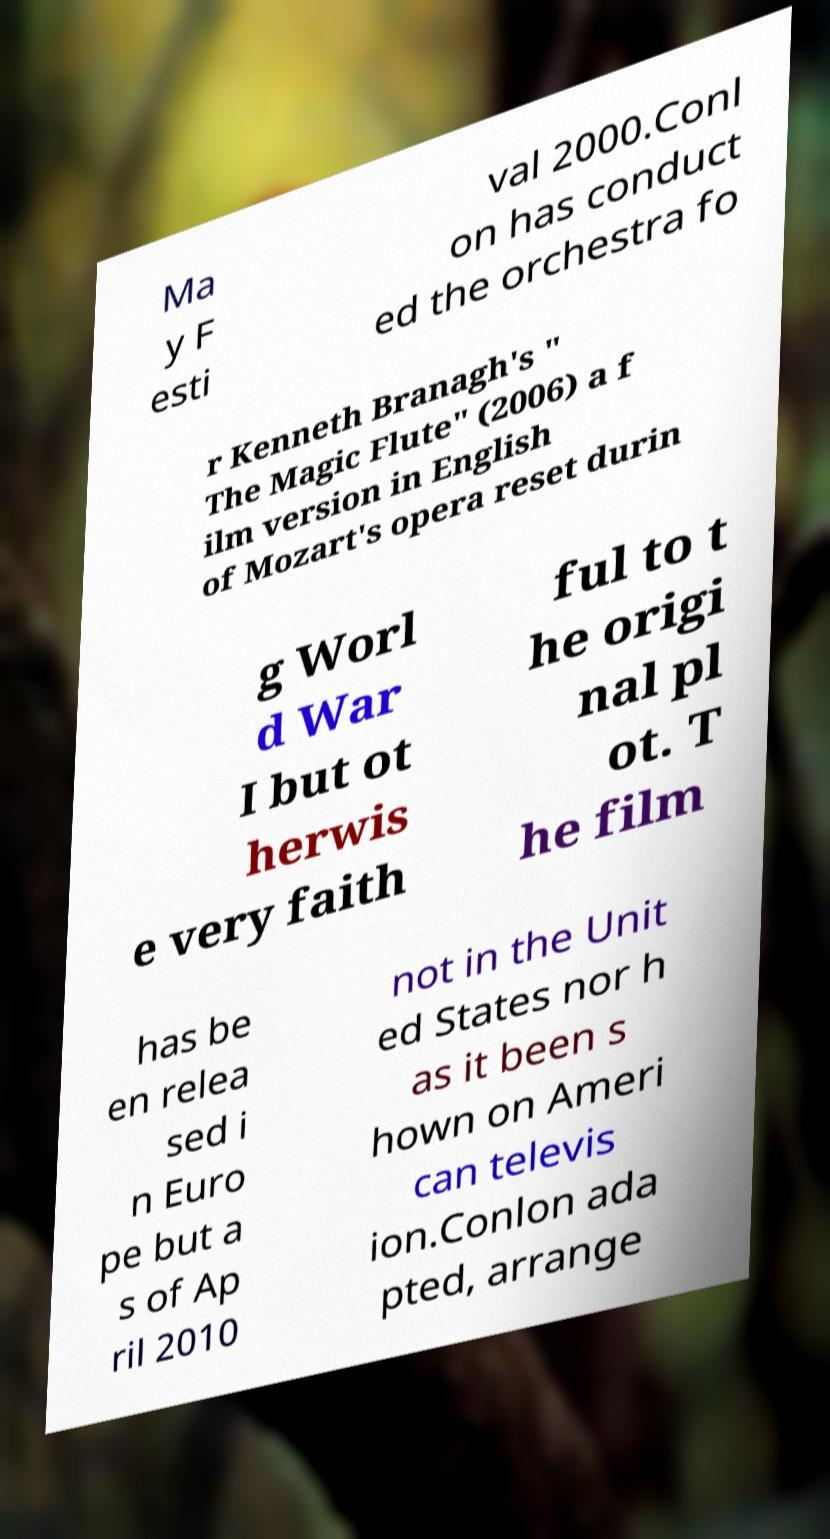Could you extract and type out the text from this image? Ma y F esti val 2000.Conl on has conduct ed the orchestra fo r Kenneth Branagh's " The Magic Flute" (2006) a f ilm version in English of Mozart's opera reset durin g Worl d War I but ot herwis e very faith ful to t he origi nal pl ot. T he film has be en relea sed i n Euro pe but a s of Ap ril 2010 not in the Unit ed States nor h as it been s hown on Ameri can televis ion.Conlon ada pted, arrange 